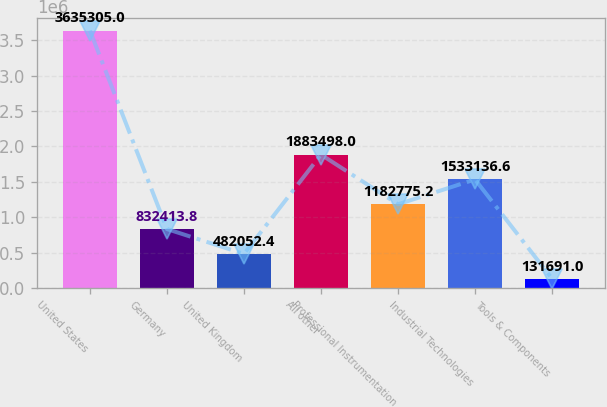<chart> <loc_0><loc_0><loc_500><loc_500><bar_chart><fcel>United States<fcel>Germany<fcel>United Kingdom<fcel>All other<fcel>Professional Instrumentation<fcel>Industrial Technologies<fcel>Tools & Components<nl><fcel>3.6353e+06<fcel>832414<fcel>482052<fcel>1.8835e+06<fcel>1.18278e+06<fcel>1.53314e+06<fcel>131691<nl></chart> 